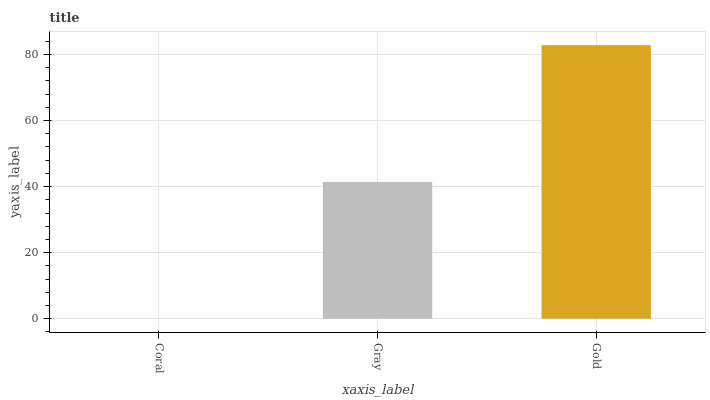Is Coral the minimum?
Answer yes or no. Yes. Is Gold the maximum?
Answer yes or no. Yes. Is Gray the minimum?
Answer yes or no. No. Is Gray the maximum?
Answer yes or no. No. Is Gray greater than Coral?
Answer yes or no. Yes. Is Coral less than Gray?
Answer yes or no. Yes. Is Coral greater than Gray?
Answer yes or no. No. Is Gray less than Coral?
Answer yes or no. No. Is Gray the high median?
Answer yes or no. Yes. Is Gray the low median?
Answer yes or no. Yes. Is Gold the high median?
Answer yes or no. No. Is Gold the low median?
Answer yes or no. No. 